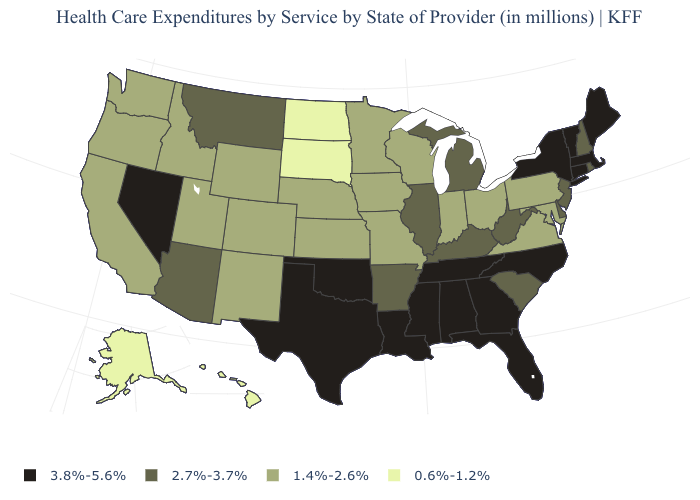What is the lowest value in states that border Illinois?
Write a very short answer. 1.4%-2.6%. What is the value of California?
Quick response, please. 1.4%-2.6%. Does Alaska have a lower value than Vermont?
Be succinct. Yes. Is the legend a continuous bar?
Give a very brief answer. No. What is the value of Tennessee?
Concise answer only. 3.8%-5.6%. What is the highest value in the USA?
Write a very short answer. 3.8%-5.6%. Name the states that have a value in the range 3.8%-5.6%?
Answer briefly. Alabama, Connecticut, Florida, Georgia, Louisiana, Maine, Massachusetts, Mississippi, Nevada, New York, North Carolina, Oklahoma, Tennessee, Texas, Vermont. Name the states that have a value in the range 1.4%-2.6%?
Be succinct. California, Colorado, Idaho, Indiana, Iowa, Kansas, Maryland, Minnesota, Missouri, Nebraska, New Mexico, Ohio, Oregon, Pennsylvania, Utah, Virginia, Washington, Wisconsin, Wyoming. What is the value of Mississippi?
Give a very brief answer. 3.8%-5.6%. What is the value of South Dakota?
Write a very short answer. 0.6%-1.2%. Among the states that border North Carolina , which have the highest value?
Be succinct. Georgia, Tennessee. Among the states that border New Hampshire , which have the lowest value?
Give a very brief answer. Maine, Massachusetts, Vermont. What is the value of Delaware?
Write a very short answer. 2.7%-3.7%. What is the lowest value in the South?
Concise answer only. 1.4%-2.6%. What is the value of Wyoming?
Quick response, please. 1.4%-2.6%. 